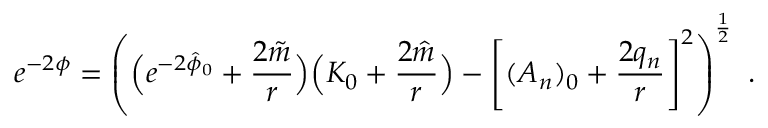Convert formula to latex. <formula><loc_0><loc_0><loc_500><loc_500>e ^ { - 2 \phi } = \left ( \left ( e ^ { - 2 \hat { \phi } _ { 0 } } + { \frac { 2 \tilde { m } } { r } } \right ) \left ( K _ { 0 } + { \frac { 2 \hat { m } } { r } } \right ) - \left [ ( A _ { n } ) _ { 0 } + { \frac { 2 q _ { n } } { r } } \right ] ^ { 2 } \right ) ^ { \frac { 1 } { 2 } } \ .</formula> 